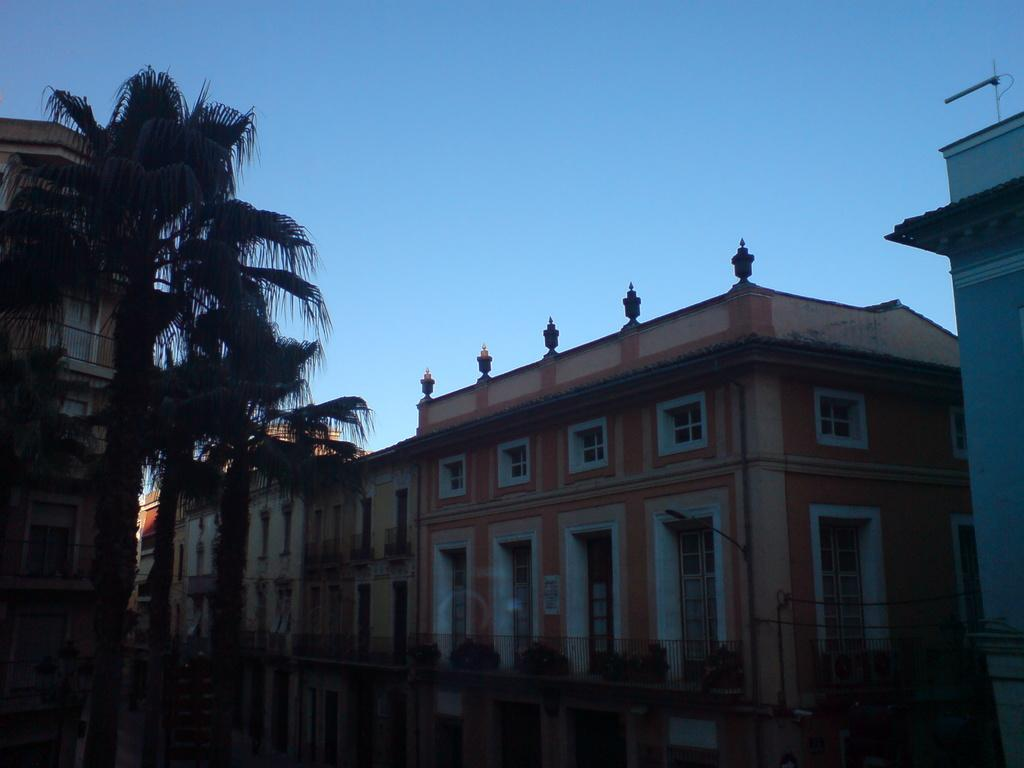What type of structures can be seen in the image? There are buildings in the image. What other natural elements are present in the image? There are trees and plants visible in the image. Can you describe the plants in the image? The plants are behind a railing in the image. What else can be seen on the pole in the image? There are wires on a pole in the image. What is visible at the top of the image? The sky is visible at the top of the image. How many snails can be seen crawling on the buildings in the image? There are no snails visible in the image; it features buildings, trees, plants, wires, and the sky. What type of bait is used to attract the birds in the scene? There is no scene with birds in the image, and therefore no bait is present. 